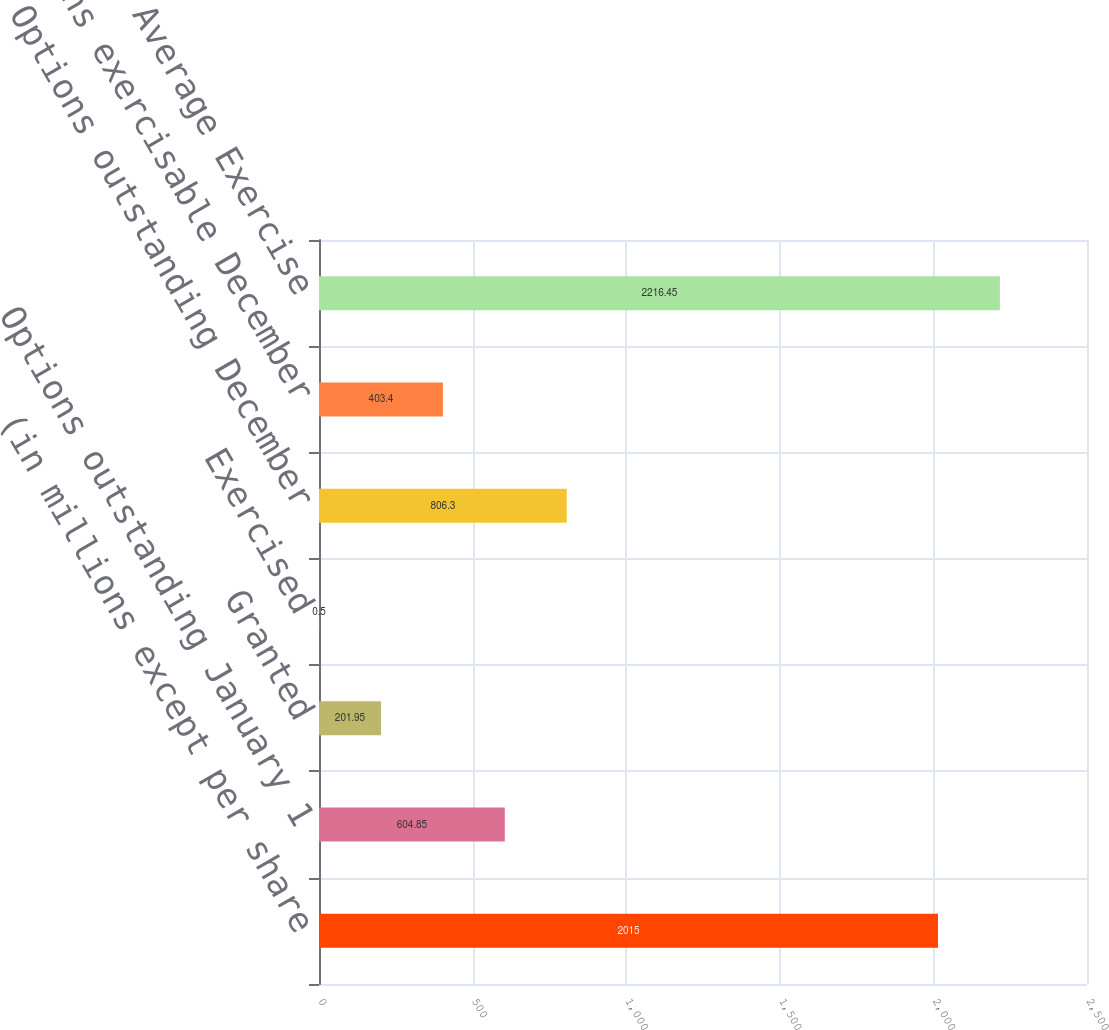Convert chart. <chart><loc_0><loc_0><loc_500><loc_500><bar_chart><fcel>(in millions except per share<fcel>Options outstanding January 1<fcel>Granted<fcel>Exercised<fcel>Options outstanding December<fcel>Options exercisable December<fcel>Weighted Average Exercise<nl><fcel>2015<fcel>604.85<fcel>201.95<fcel>0.5<fcel>806.3<fcel>403.4<fcel>2216.45<nl></chart> 